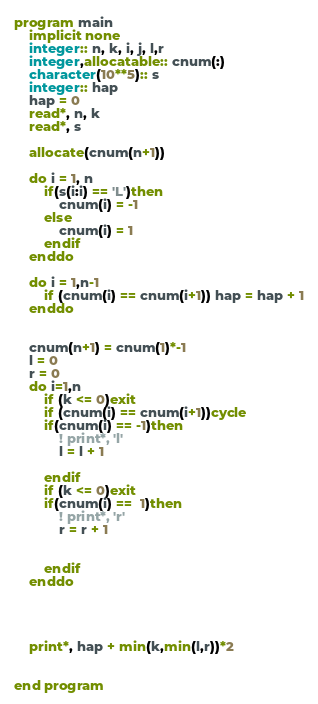<code> <loc_0><loc_0><loc_500><loc_500><_FORTRAN_>program main
    implicit none
    integer:: n, k, i, j, l,r
    integer,allocatable:: cnum(:)
    character(10**5):: s
    integer:: hap
    hap = 0
    read*, n, k
    read*, s
    
    allocate(cnum(n+1))

    do i = 1, n
        if(s(i:i) == 'L')then
            cnum(i) = -1
        else
            cnum(i) = 1
        endif
    enddo

    do i = 1,n-1
        if (cnum(i) == cnum(i+1)) hap = hap + 1
    enddo


    cnum(n+1) = cnum(1)*-1
    l = 0
    r = 0
    do i=1,n
        if (k <= 0)exit
        if (cnum(i) == cnum(i+1))cycle
        if(cnum(i) == -1)then
            ! print*, 'l'
            l = l + 1

        endif
        if (k <= 0)exit
        if(cnum(i) ==  1)then
            ! print*, 'r'
            r = r + 1


        endif
    enddo

   


    print*, hap + min(k,min(l,r))*2
    

end program</code> 